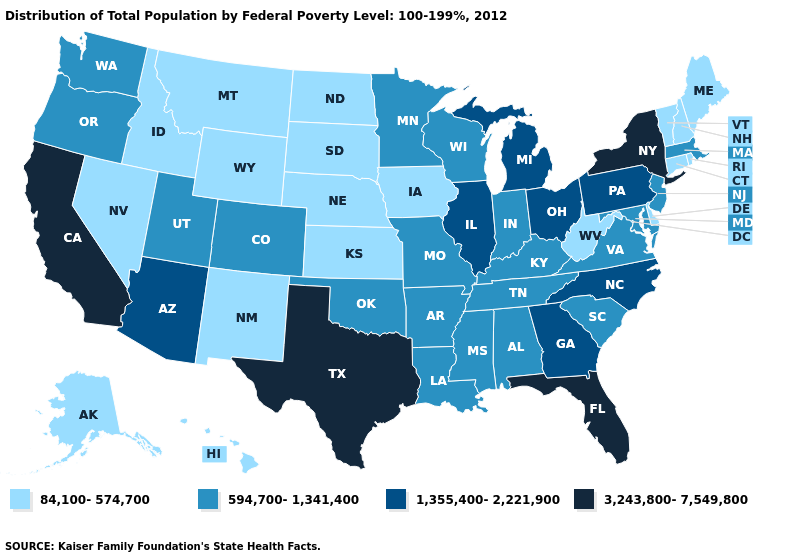Name the states that have a value in the range 594,700-1,341,400?
Write a very short answer. Alabama, Arkansas, Colorado, Indiana, Kentucky, Louisiana, Maryland, Massachusetts, Minnesota, Mississippi, Missouri, New Jersey, Oklahoma, Oregon, South Carolina, Tennessee, Utah, Virginia, Washington, Wisconsin. Which states have the highest value in the USA?
Keep it brief. California, Florida, New York, Texas. What is the value of Tennessee?
Quick response, please. 594,700-1,341,400. What is the highest value in the South ?
Write a very short answer. 3,243,800-7,549,800. Among the states that border California , which have the lowest value?
Give a very brief answer. Nevada. Is the legend a continuous bar?
Write a very short answer. No. What is the value of Wisconsin?
Write a very short answer. 594,700-1,341,400. Name the states that have a value in the range 84,100-574,700?
Concise answer only. Alaska, Connecticut, Delaware, Hawaii, Idaho, Iowa, Kansas, Maine, Montana, Nebraska, Nevada, New Hampshire, New Mexico, North Dakota, Rhode Island, South Dakota, Vermont, West Virginia, Wyoming. Does Wisconsin have the lowest value in the MidWest?
Keep it brief. No. Among the states that border Missouri , which have the lowest value?
Give a very brief answer. Iowa, Kansas, Nebraska. Does Texas have the highest value in the South?
Concise answer only. Yes. What is the value of Kansas?
Keep it brief. 84,100-574,700. How many symbols are there in the legend?
Short answer required. 4. Name the states that have a value in the range 84,100-574,700?
Concise answer only. Alaska, Connecticut, Delaware, Hawaii, Idaho, Iowa, Kansas, Maine, Montana, Nebraska, Nevada, New Hampshire, New Mexico, North Dakota, Rhode Island, South Dakota, Vermont, West Virginia, Wyoming. Does Alabama have the highest value in the USA?
Quick response, please. No. 